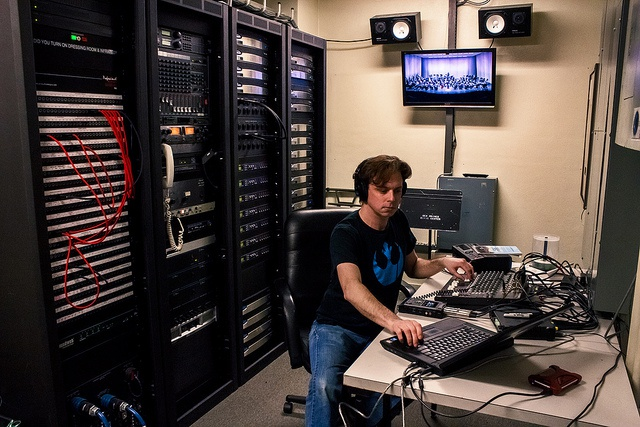Describe the objects in this image and their specific colors. I can see people in black, brown, navy, and blue tones, chair in black, gray, and lightgray tones, tv in black, lavender, violet, and blue tones, laptop in black, gray, and darkgray tones, and book in black, lightgray, darkgray, and gray tones in this image. 